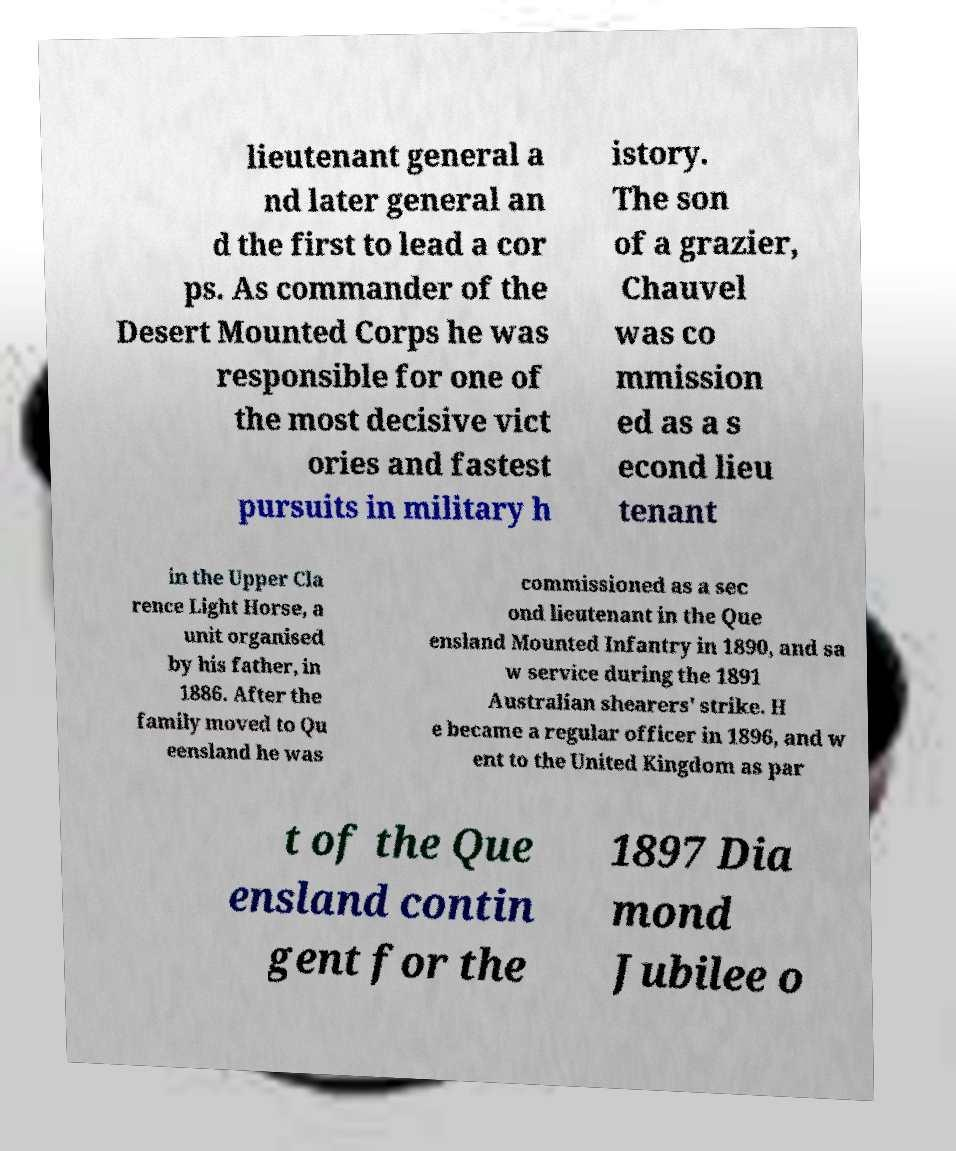What messages or text are displayed in this image? I need them in a readable, typed format. lieutenant general a nd later general an d the first to lead a cor ps. As commander of the Desert Mounted Corps he was responsible for one of the most decisive vict ories and fastest pursuits in military h istory. The son of a grazier, Chauvel was co mmission ed as a s econd lieu tenant in the Upper Cla rence Light Horse, a unit organised by his father, in 1886. After the family moved to Qu eensland he was commissioned as a sec ond lieutenant in the Que ensland Mounted Infantry in 1890, and sa w service during the 1891 Australian shearers' strike. H e became a regular officer in 1896, and w ent to the United Kingdom as par t of the Que ensland contin gent for the 1897 Dia mond Jubilee o 